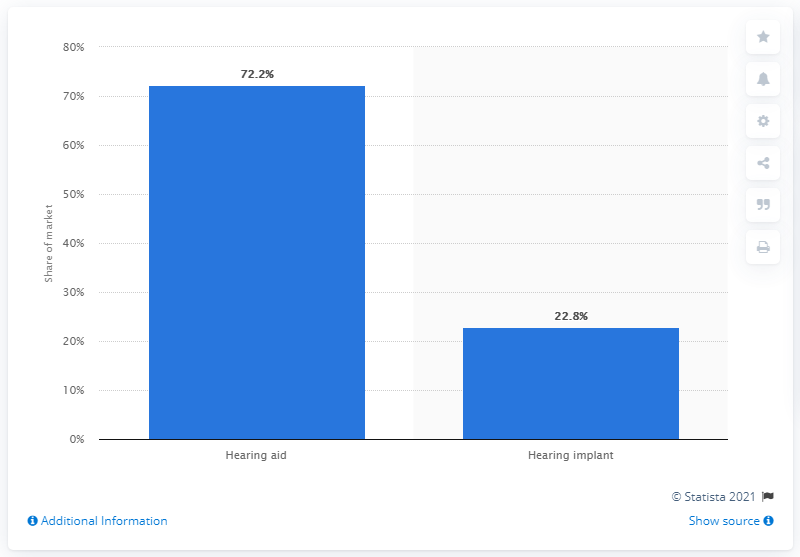Highlight a few significant elements in this photo. In 2015, hearing implants accounted for approximately 22.8% of the market. In 2015, hearing aids accounted for approximately 72.2% of the global hearing aid market. 